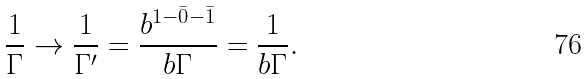<formula> <loc_0><loc_0><loc_500><loc_500>\frac { 1 } { \Gamma } \rightarrow \frac { 1 } { \Gamma ^ { \prime } } = \frac { b ^ { 1 - \bar { 0 } - \bar { 1 } } } { b \Gamma } = \frac { 1 } { b \Gamma } .</formula> 